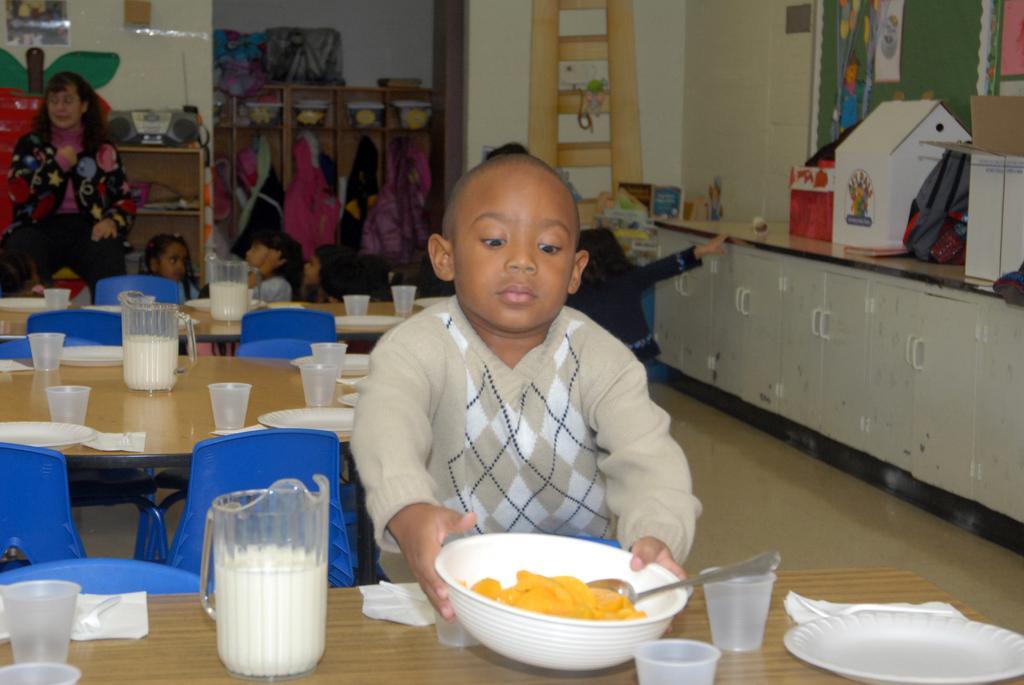Describe this image in one or two sentences. In this image there is a child standing and holding a bowl in his hands. The bowl consists of some food item and spoon in it. On the table there is a jug with milk and glasses along with the plates on it. In the background there is a woman standing and children are sitting down on the floor. On the right side of the image there are cupboards and some things are placed on that. This is the wall with a painting on it. 